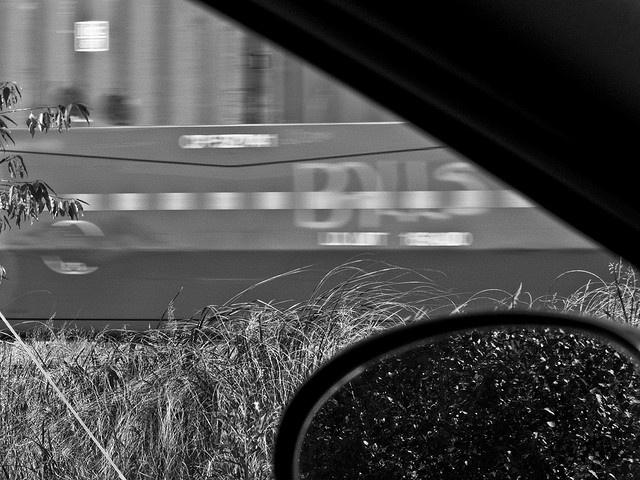Describe the objects in this image and their specific colors. I can see a train in gray, black, and lightgray tones in this image. 